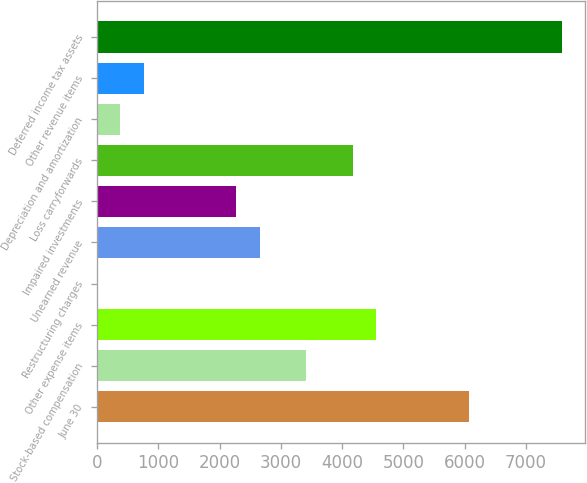Convert chart to OTSL. <chart><loc_0><loc_0><loc_500><loc_500><bar_chart><fcel>June 30<fcel>Stock-based compensation<fcel>Other expense items<fcel>Restructuring charges<fcel>Unearned revenue<fcel>Impaired investments<fcel>Loss carryforwards<fcel>Depreciation and amortization<fcel>Other revenue items<fcel>Deferred income tax assets<nl><fcel>6067.85<fcel>3413.87<fcel>4551.29<fcel>1.61<fcel>2655.59<fcel>2276.45<fcel>4172.15<fcel>380.75<fcel>759.89<fcel>7584.41<nl></chart> 